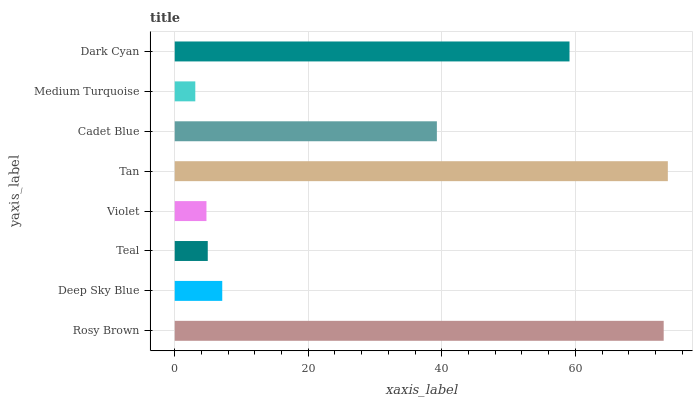Is Medium Turquoise the minimum?
Answer yes or no. Yes. Is Tan the maximum?
Answer yes or no. Yes. Is Deep Sky Blue the minimum?
Answer yes or no. No. Is Deep Sky Blue the maximum?
Answer yes or no. No. Is Rosy Brown greater than Deep Sky Blue?
Answer yes or no. Yes. Is Deep Sky Blue less than Rosy Brown?
Answer yes or no. Yes. Is Deep Sky Blue greater than Rosy Brown?
Answer yes or no. No. Is Rosy Brown less than Deep Sky Blue?
Answer yes or no. No. Is Cadet Blue the high median?
Answer yes or no. Yes. Is Deep Sky Blue the low median?
Answer yes or no. Yes. Is Deep Sky Blue the high median?
Answer yes or no. No. Is Violet the low median?
Answer yes or no. No. 